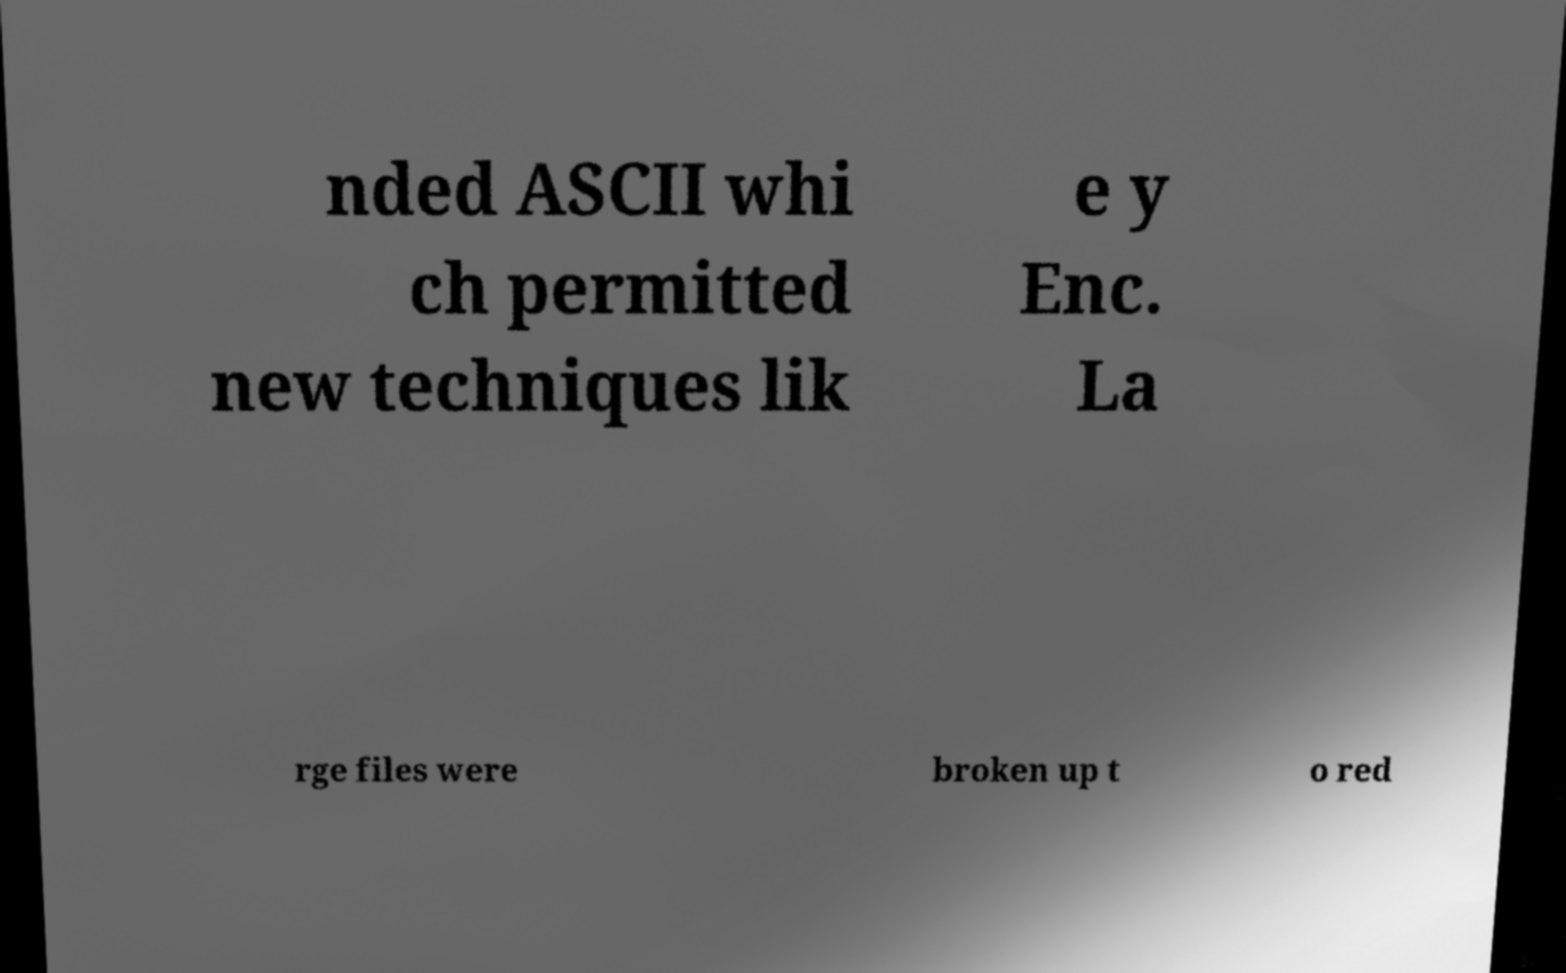There's text embedded in this image that I need extracted. Can you transcribe it verbatim? nded ASCII whi ch permitted new techniques lik e y Enc. La rge files were broken up t o red 